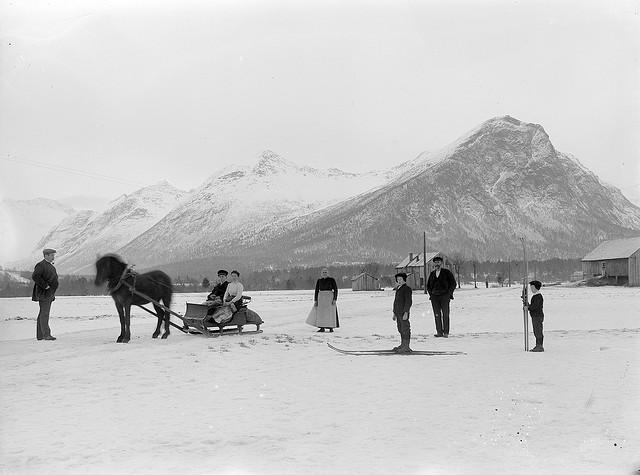How many kids are here?
Keep it brief. 2. How many animals are in this photo?
Give a very brief answer. 1. How deep is the snow?
Be succinct. Not deep. 